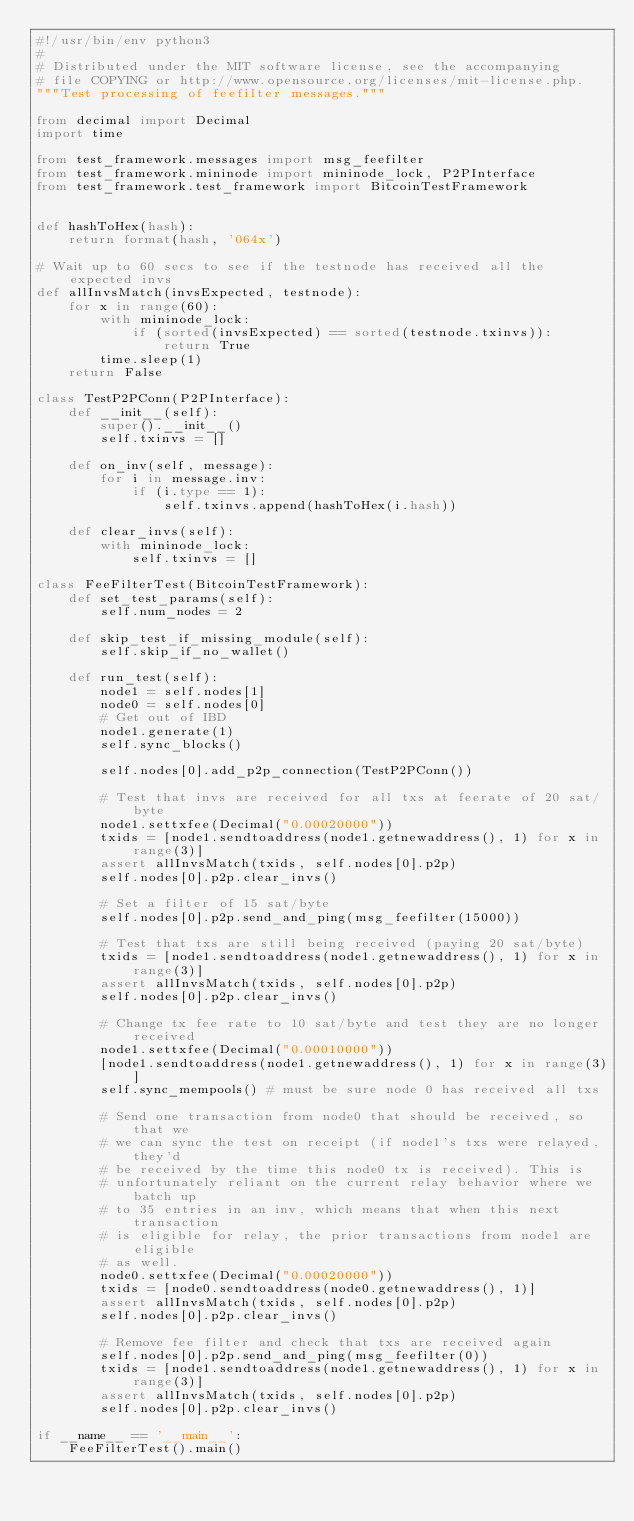Convert code to text. <code><loc_0><loc_0><loc_500><loc_500><_Python_>#!/usr/bin/env python3
# 
# Distributed under the MIT software license, see the accompanying
# file COPYING or http://www.opensource.org/licenses/mit-license.php.
"""Test processing of feefilter messages."""

from decimal import Decimal
import time

from test_framework.messages import msg_feefilter
from test_framework.mininode import mininode_lock, P2PInterface
from test_framework.test_framework import BitcoinTestFramework


def hashToHex(hash):
    return format(hash, '064x')

# Wait up to 60 secs to see if the testnode has received all the expected invs
def allInvsMatch(invsExpected, testnode):
    for x in range(60):
        with mininode_lock:
            if (sorted(invsExpected) == sorted(testnode.txinvs)):
                return True
        time.sleep(1)
    return False

class TestP2PConn(P2PInterface):
    def __init__(self):
        super().__init__()
        self.txinvs = []

    def on_inv(self, message):
        for i in message.inv:
            if (i.type == 1):
                self.txinvs.append(hashToHex(i.hash))

    def clear_invs(self):
        with mininode_lock:
            self.txinvs = []

class FeeFilterTest(BitcoinTestFramework):
    def set_test_params(self):
        self.num_nodes = 2

    def skip_test_if_missing_module(self):
        self.skip_if_no_wallet()

    def run_test(self):
        node1 = self.nodes[1]
        node0 = self.nodes[0]
        # Get out of IBD
        node1.generate(1)
        self.sync_blocks()

        self.nodes[0].add_p2p_connection(TestP2PConn())

        # Test that invs are received for all txs at feerate of 20 sat/byte
        node1.settxfee(Decimal("0.00020000"))
        txids = [node1.sendtoaddress(node1.getnewaddress(), 1) for x in range(3)]
        assert allInvsMatch(txids, self.nodes[0].p2p)
        self.nodes[0].p2p.clear_invs()

        # Set a filter of 15 sat/byte
        self.nodes[0].p2p.send_and_ping(msg_feefilter(15000))

        # Test that txs are still being received (paying 20 sat/byte)
        txids = [node1.sendtoaddress(node1.getnewaddress(), 1) for x in range(3)]
        assert allInvsMatch(txids, self.nodes[0].p2p)
        self.nodes[0].p2p.clear_invs()

        # Change tx fee rate to 10 sat/byte and test they are no longer received
        node1.settxfee(Decimal("0.00010000"))
        [node1.sendtoaddress(node1.getnewaddress(), 1) for x in range(3)]
        self.sync_mempools() # must be sure node 0 has received all txs

        # Send one transaction from node0 that should be received, so that we
        # we can sync the test on receipt (if node1's txs were relayed, they'd
        # be received by the time this node0 tx is received). This is
        # unfortunately reliant on the current relay behavior where we batch up
        # to 35 entries in an inv, which means that when this next transaction
        # is eligible for relay, the prior transactions from node1 are eligible
        # as well.
        node0.settxfee(Decimal("0.00020000"))
        txids = [node0.sendtoaddress(node0.getnewaddress(), 1)]
        assert allInvsMatch(txids, self.nodes[0].p2p)
        self.nodes[0].p2p.clear_invs()

        # Remove fee filter and check that txs are received again
        self.nodes[0].p2p.send_and_ping(msg_feefilter(0))
        txids = [node1.sendtoaddress(node1.getnewaddress(), 1) for x in range(3)]
        assert allInvsMatch(txids, self.nodes[0].p2p)
        self.nodes[0].p2p.clear_invs()

if __name__ == '__main__':
    FeeFilterTest().main()
</code> 